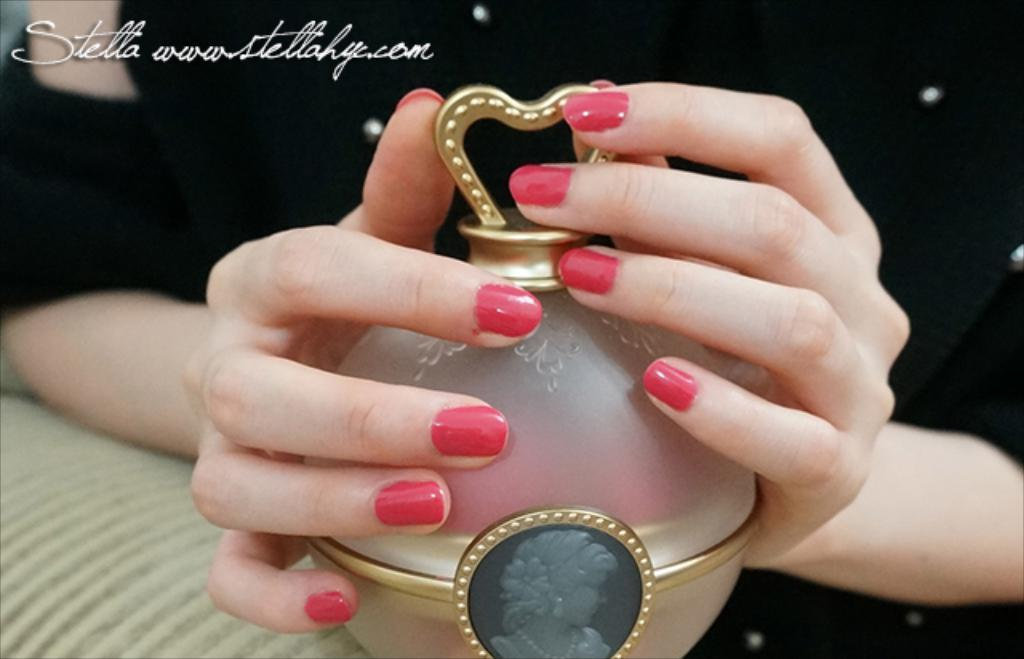<image>
Give a short and clear explanation of the subsequent image. A woman with painted nails behind the words Stella. 